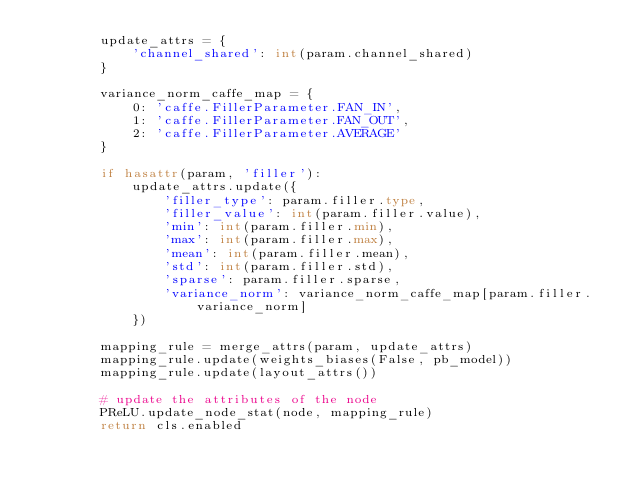<code> <loc_0><loc_0><loc_500><loc_500><_Python_>        update_attrs = {
            'channel_shared': int(param.channel_shared)
        }

        variance_norm_caffe_map = {
            0: 'caffe.FillerParameter.FAN_IN',
            1: 'caffe.FillerParameter.FAN_OUT',
            2: 'caffe.FillerParameter.AVERAGE'
        }

        if hasattr(param, 'filler'):
            update_attrs.update({
                'filler_type': param.filler.type,
                'filler_value': int(param.filler.value),
                'min': int(param.filler.min),
                'max': int(param.filler.max),
                'mean': int(param.filler.mean),
                'std': int(param.filler.std),
                'sparse': param.filler.sparse,
                'variance_norm': variance_norm_caffe_map[param.filler.variance_norm]
            })

        mapping_rule = merge_attrs(param, update_attrs)
        mapping_rule.update(weights_biases(False, pb_model))
        mapping_rule.update(layout_attrs())

        # update the attributes of the node
        PReLU.update_node_stat(node, mapping_rule)
        return cls.enabled
</code> 